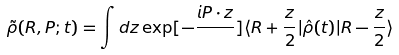<formula> <loc_0><loc_0><loc_500><loc_500>\tilde { \rho } ( { R , P } ; t ) = \int { d { z } \exp [ - \frac { i P \cdot z } { } ] \langle { R } + \frac { z } { 2 } | \hat { \rho } ( t ) | { R } - \frac { z } { 2 } \rangle }</formula> 